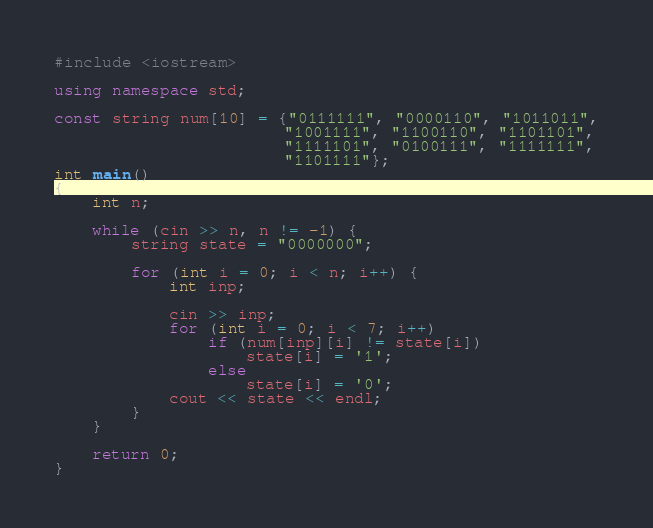<code> <loc_0><loc_0><loc_500><loc_500><_C++_>#include <iostream>

using namespace std;

const string num[10] = {"0111111", "0000110", "1011011",
                        "1001111", "1100110", "1101101",
                        "1111101", "0100111", "1111111",
                        "1101111"};
int main()
{
    int n;

    while (cin >> n, n != -1) {
        string state = "0000000";

        for (int i = 0; i < n; i++) {
            int inp; 
            
            cin >> inp;
            for (int i = 0; i < 7; i++)
                if (num[inp][i] != state[i]) 
                    state[i] = '1';
                else
                    state[i] = '0';
            cout << state << endl;
        }
    }

    return 0;
}</code> 